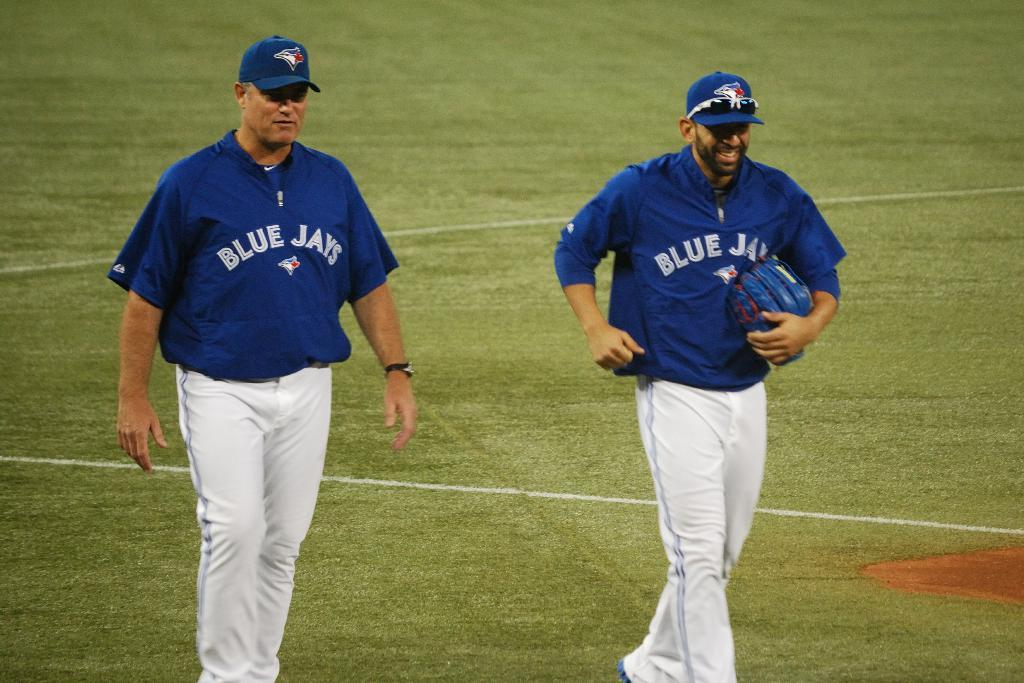<image>
Relay a brief, clear account of the picture shown. two blue jay players are out on the field 